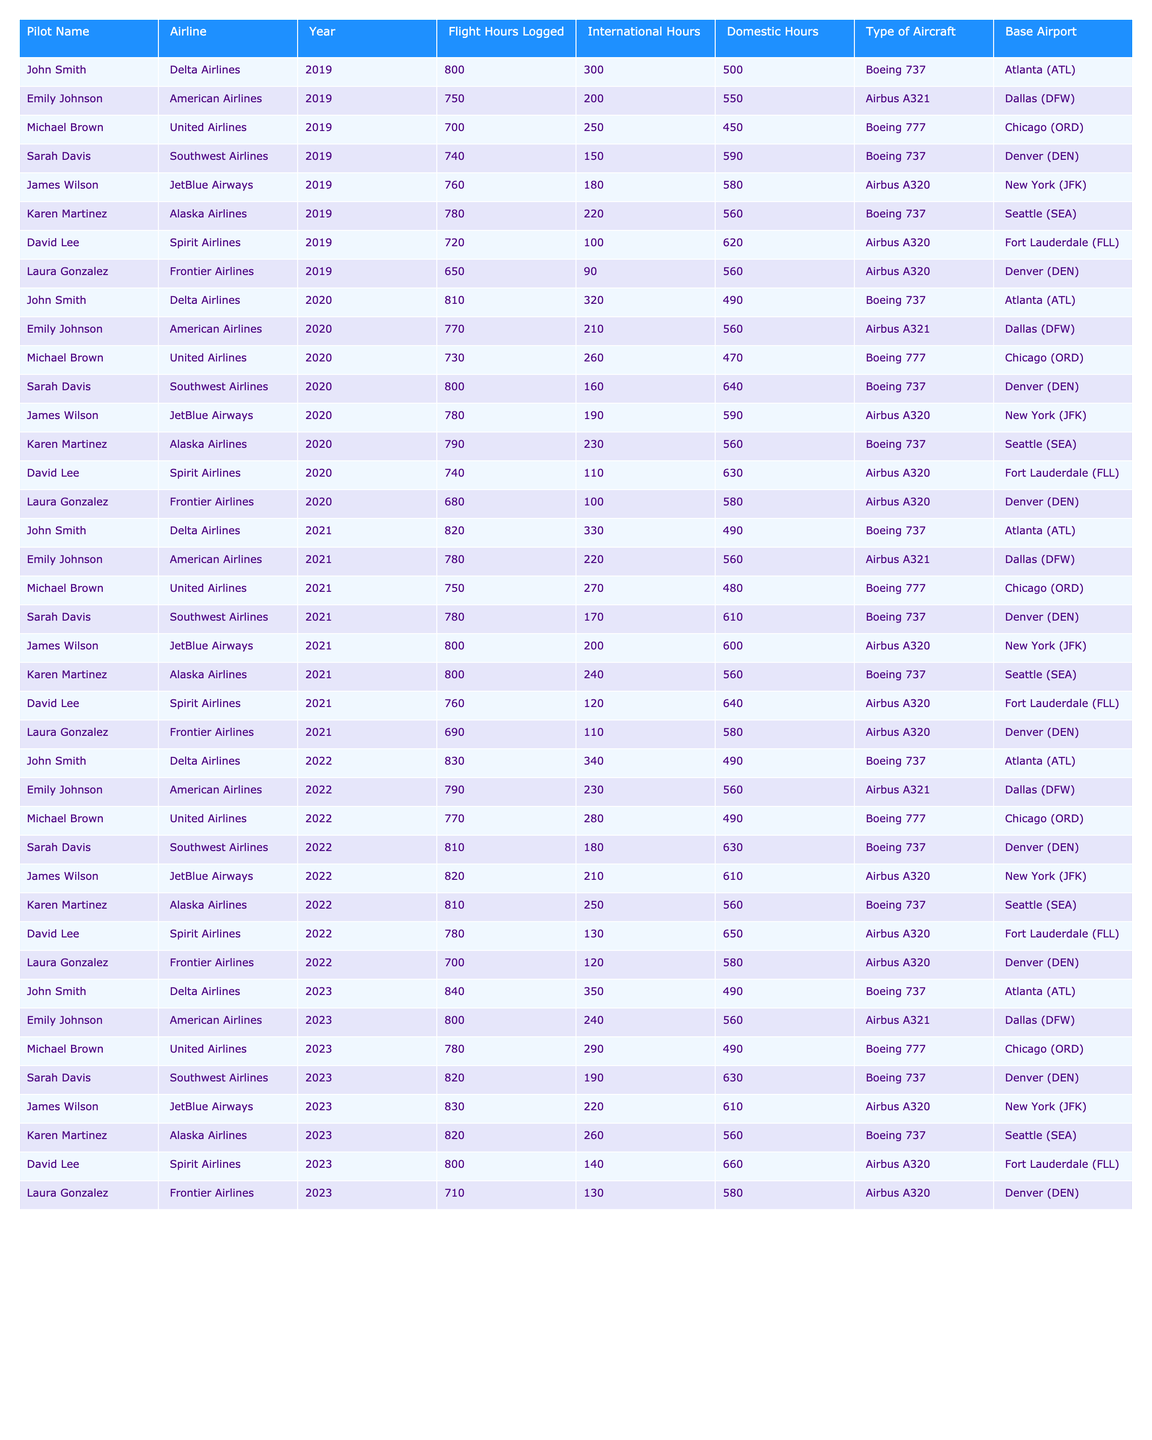What is the total flight hours logged by John Smith in 2022? In 2022, John Smith logged 830 flight hours, as seen in the table for that year.
Answer: 830 Which airline had the highest logged flight hours by a pilot in 2023? Out of the pilots in 2023, James Wilson from JetBlue Airways logged 830 hours, which is the highest logged flight hours in that year.
Answer: JetBlue Airways What is the average domestic flight hours logged by pilots in 2021? The domestic flight hours for 2021 are: 490, 560, 480, 610, 600, 560, 640, and 580. Summing these gives 4,280, and dividing by 8 (the number of pilots) gives an average of 535 domestic flight hours.
Answer: 535 Did Emily Johnson log more international hours than Karen Martinez in 2020? In 2020, Emily Johnson logged 210 international hours while Karen Martinez logged 230. Since 210 is less than 230, the answer is no.
Answer: No What is the trend in flight hours logged by Karen Martinez from 2019 to 2023? Karen’s logged hours are: 780 (2019), 790 (2020), 800 (2021), 810 (2022), and 820 (2023). This shows an increasing trend each year, increasing by 10 hours each year.
Answer: Increasing What is the difference in total flight hours logged between Sarah Davis and David Lee over the five years? Total for Sarah Davis: 740 + 800 + 780 + 810 + 820 = 3950. Total for David Lee: 720 + 740 + 760 + 780 + 800 = 3800. The difference is 3950 - 3800 = 150 flight hours.
Answer: 150 Which pilot logged the least flight hours in 2020? Reviewing the table for 2020, Laura Gonzalez logged 680 hours, which is less than any other pilot's logged hours for that year.
Answer: Laura Gonzalez What is the total number of international flight hours logged by Michael Brown from 2019 to 2023? The international hours for Michael Brown are: 250 (2019), 260 (2020), 270 (2021), 280 (2022), and 290 (2023). Summing these gives a total of 1350 international flight hours.
Answer: 1350 Is there any pilot who logged exactly 700 flight hours in any year? Checking the data, Laura Gonzalez logged exactly 700 hours in 2022, so there is a pilot who logged that amount.
Answer: Yes Who logged the most domestic flight hours in 2021, and how many? In 2021, Sarah Davis logged 610 domestic hours, which is the most compared to other pilots that year.
Answer: Sarah Davis, 610 What is the overall trend in total flight hours logged from 2019 to 2023? Analyzing the total logged hours for each year: 2019 (total: 5630), 2020 (total: 5540), 2021 (total: 6120), 2022 (total: 6190), and 2023 (total: 6270). The total flight hours show an overall increasing trend from 2019 to 2023.
Answer: Overall increasing trend 